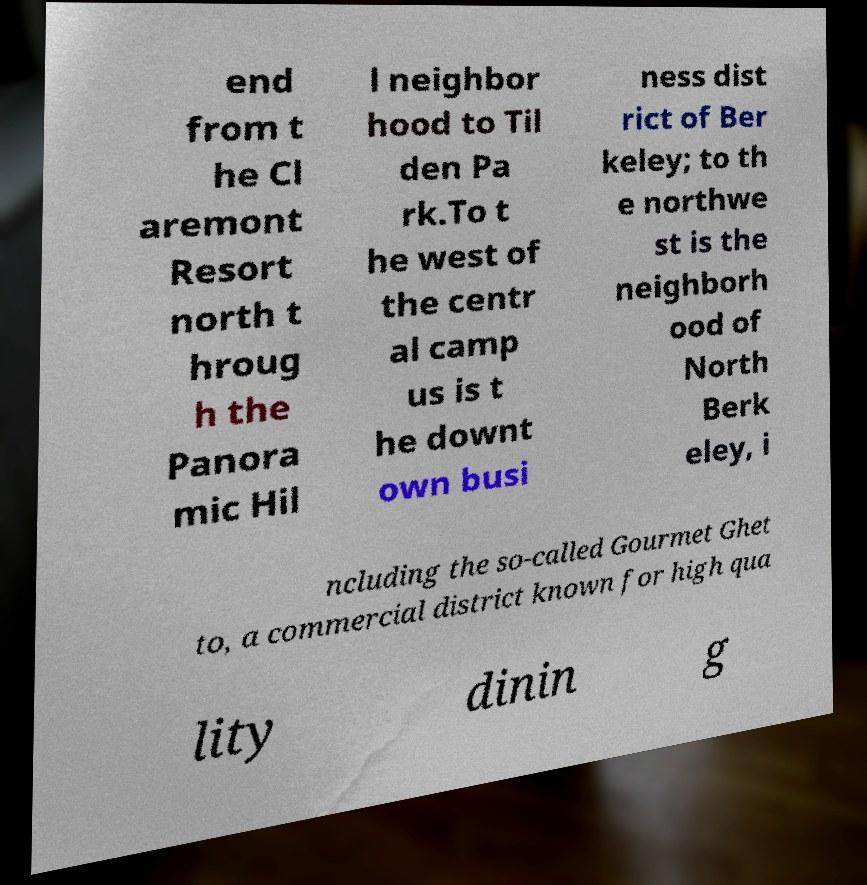Can you read and provide the text displayed in the image?This photo seems to have some interesting text. Can you extract and type it out for me? end from t he Cl aremont Resort north t hroug h the Panora mic Hil l neighbor hood to Til den Pa rk.To t he west of the centr al camp us is t he downt own busi ness dist rict of Ber keley; to th e northwe st is the neighborh ood of North Berk eley, i ncluding the so-called Gourmet Ghet to, a commercial district known for high qua lity dinin g 